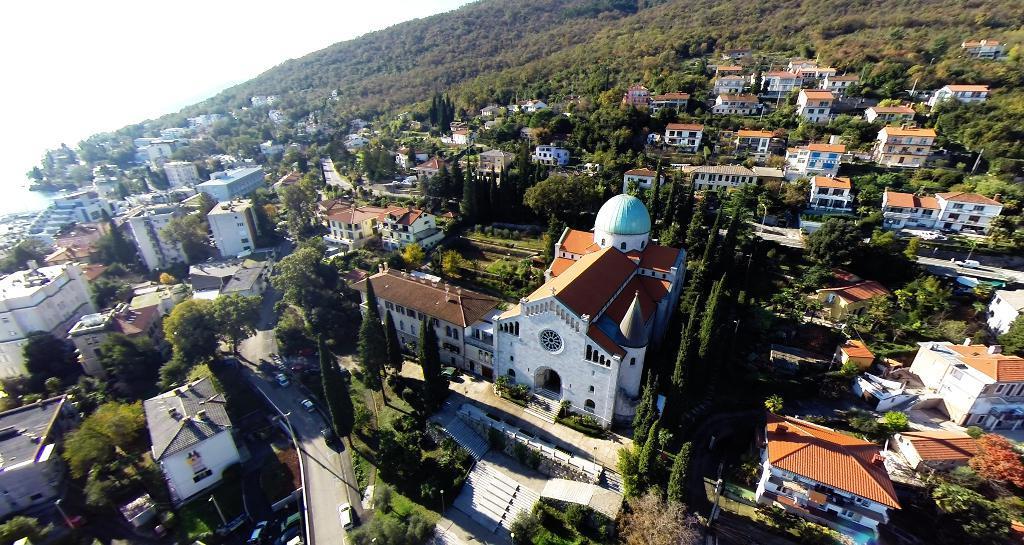Describe this image in one or two sentences. In this image there are buildings, trees, vehicles, roads, poles, plants, grass, sky and objects. Vehicles are on the roads. 